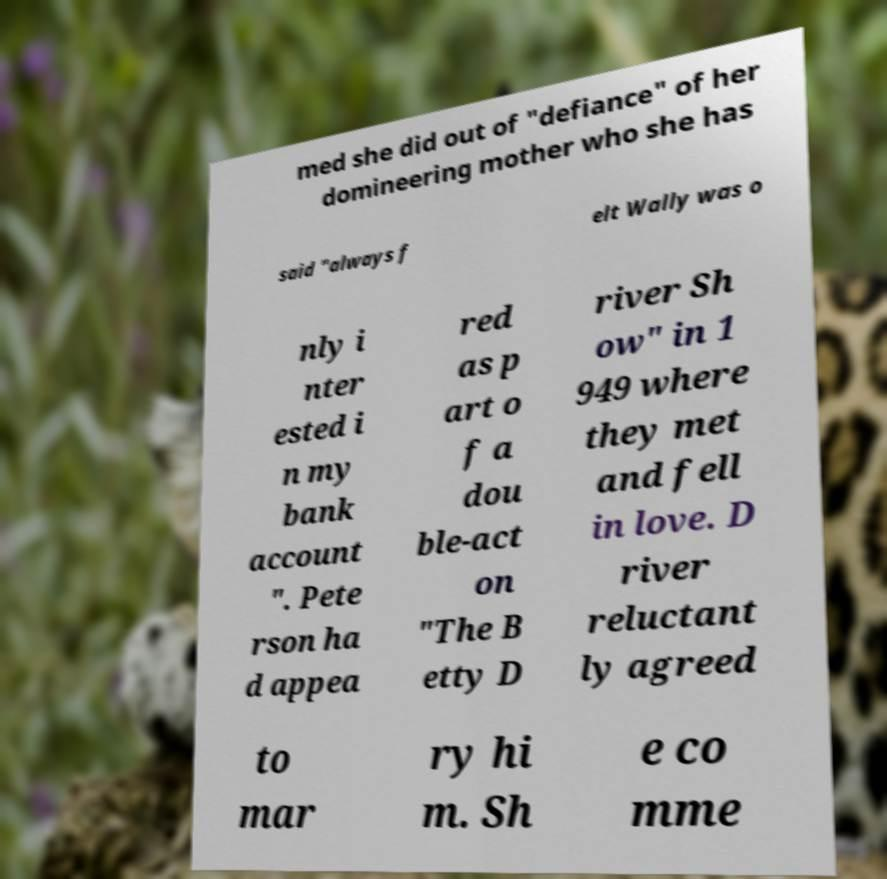I need the written content from this picture converted into text. Can you do that? med she did out of "defiance" of her domineering mother who she has said "always f elt Wally was o nly i nter ested i n my bank account ". Pete rson ha d appea red as p art o f a dou ble-act on "The B etty D river Sh ow" in 1 949 where they met and fell in love. D river reluctant ly agreed to mar ry hi m. Sh e co mme 